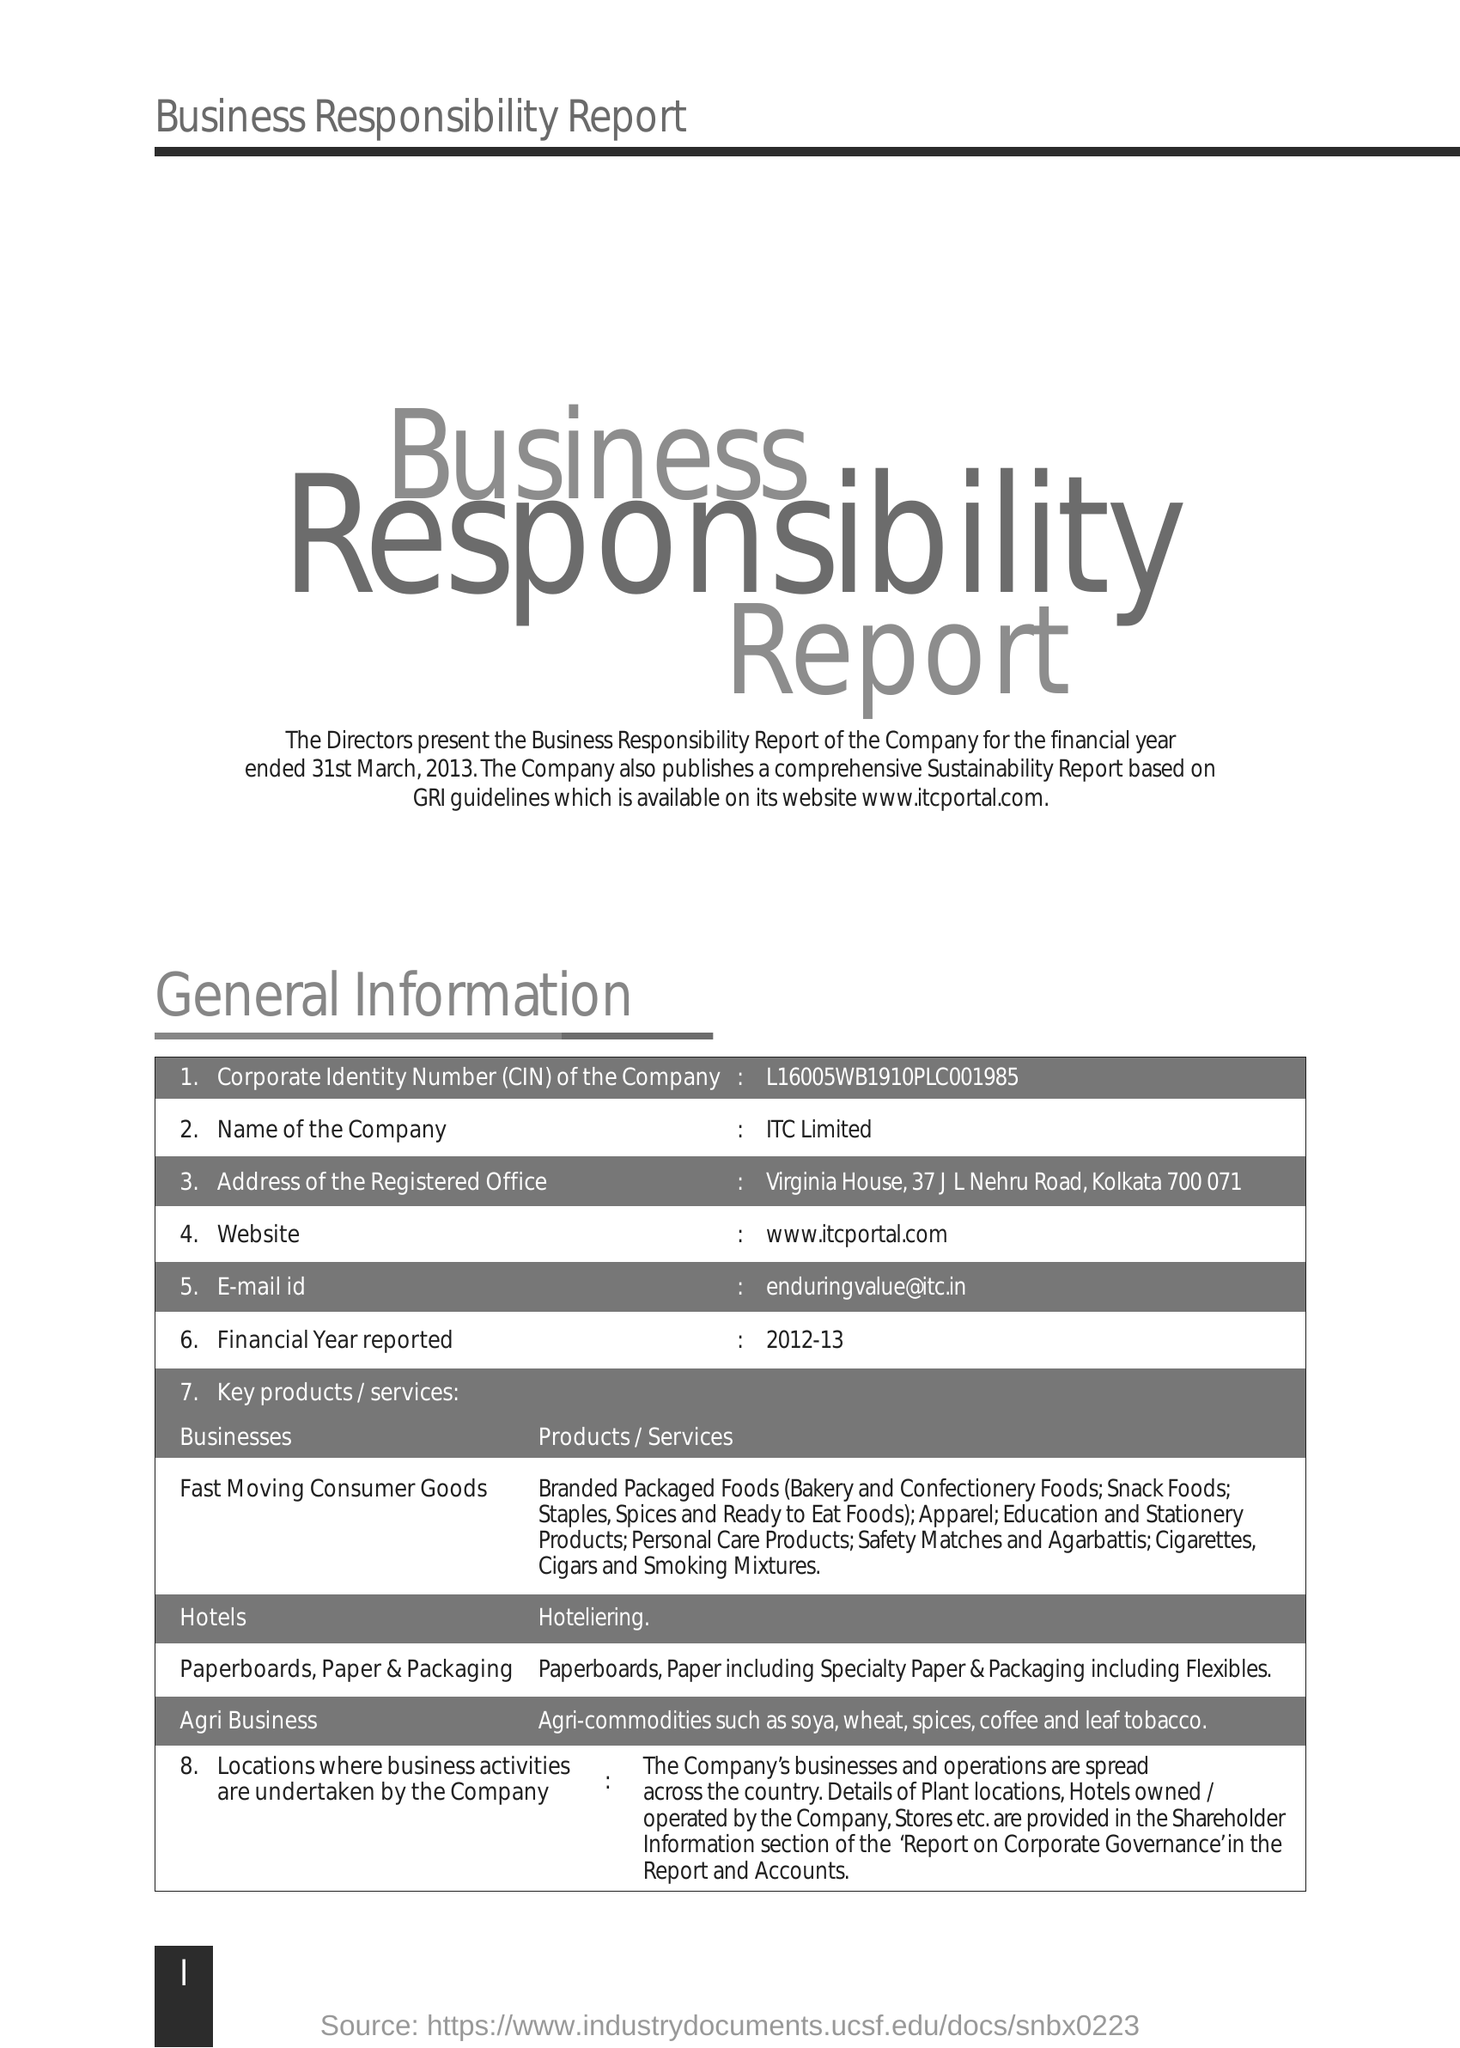Highlight a few significant elements in this photo. The full form of CIN mentioned in the form is Corporate Identity Number. The company named ITC Limited. The company's Corporate Identity Number is L16005WB1910PLC001985. 